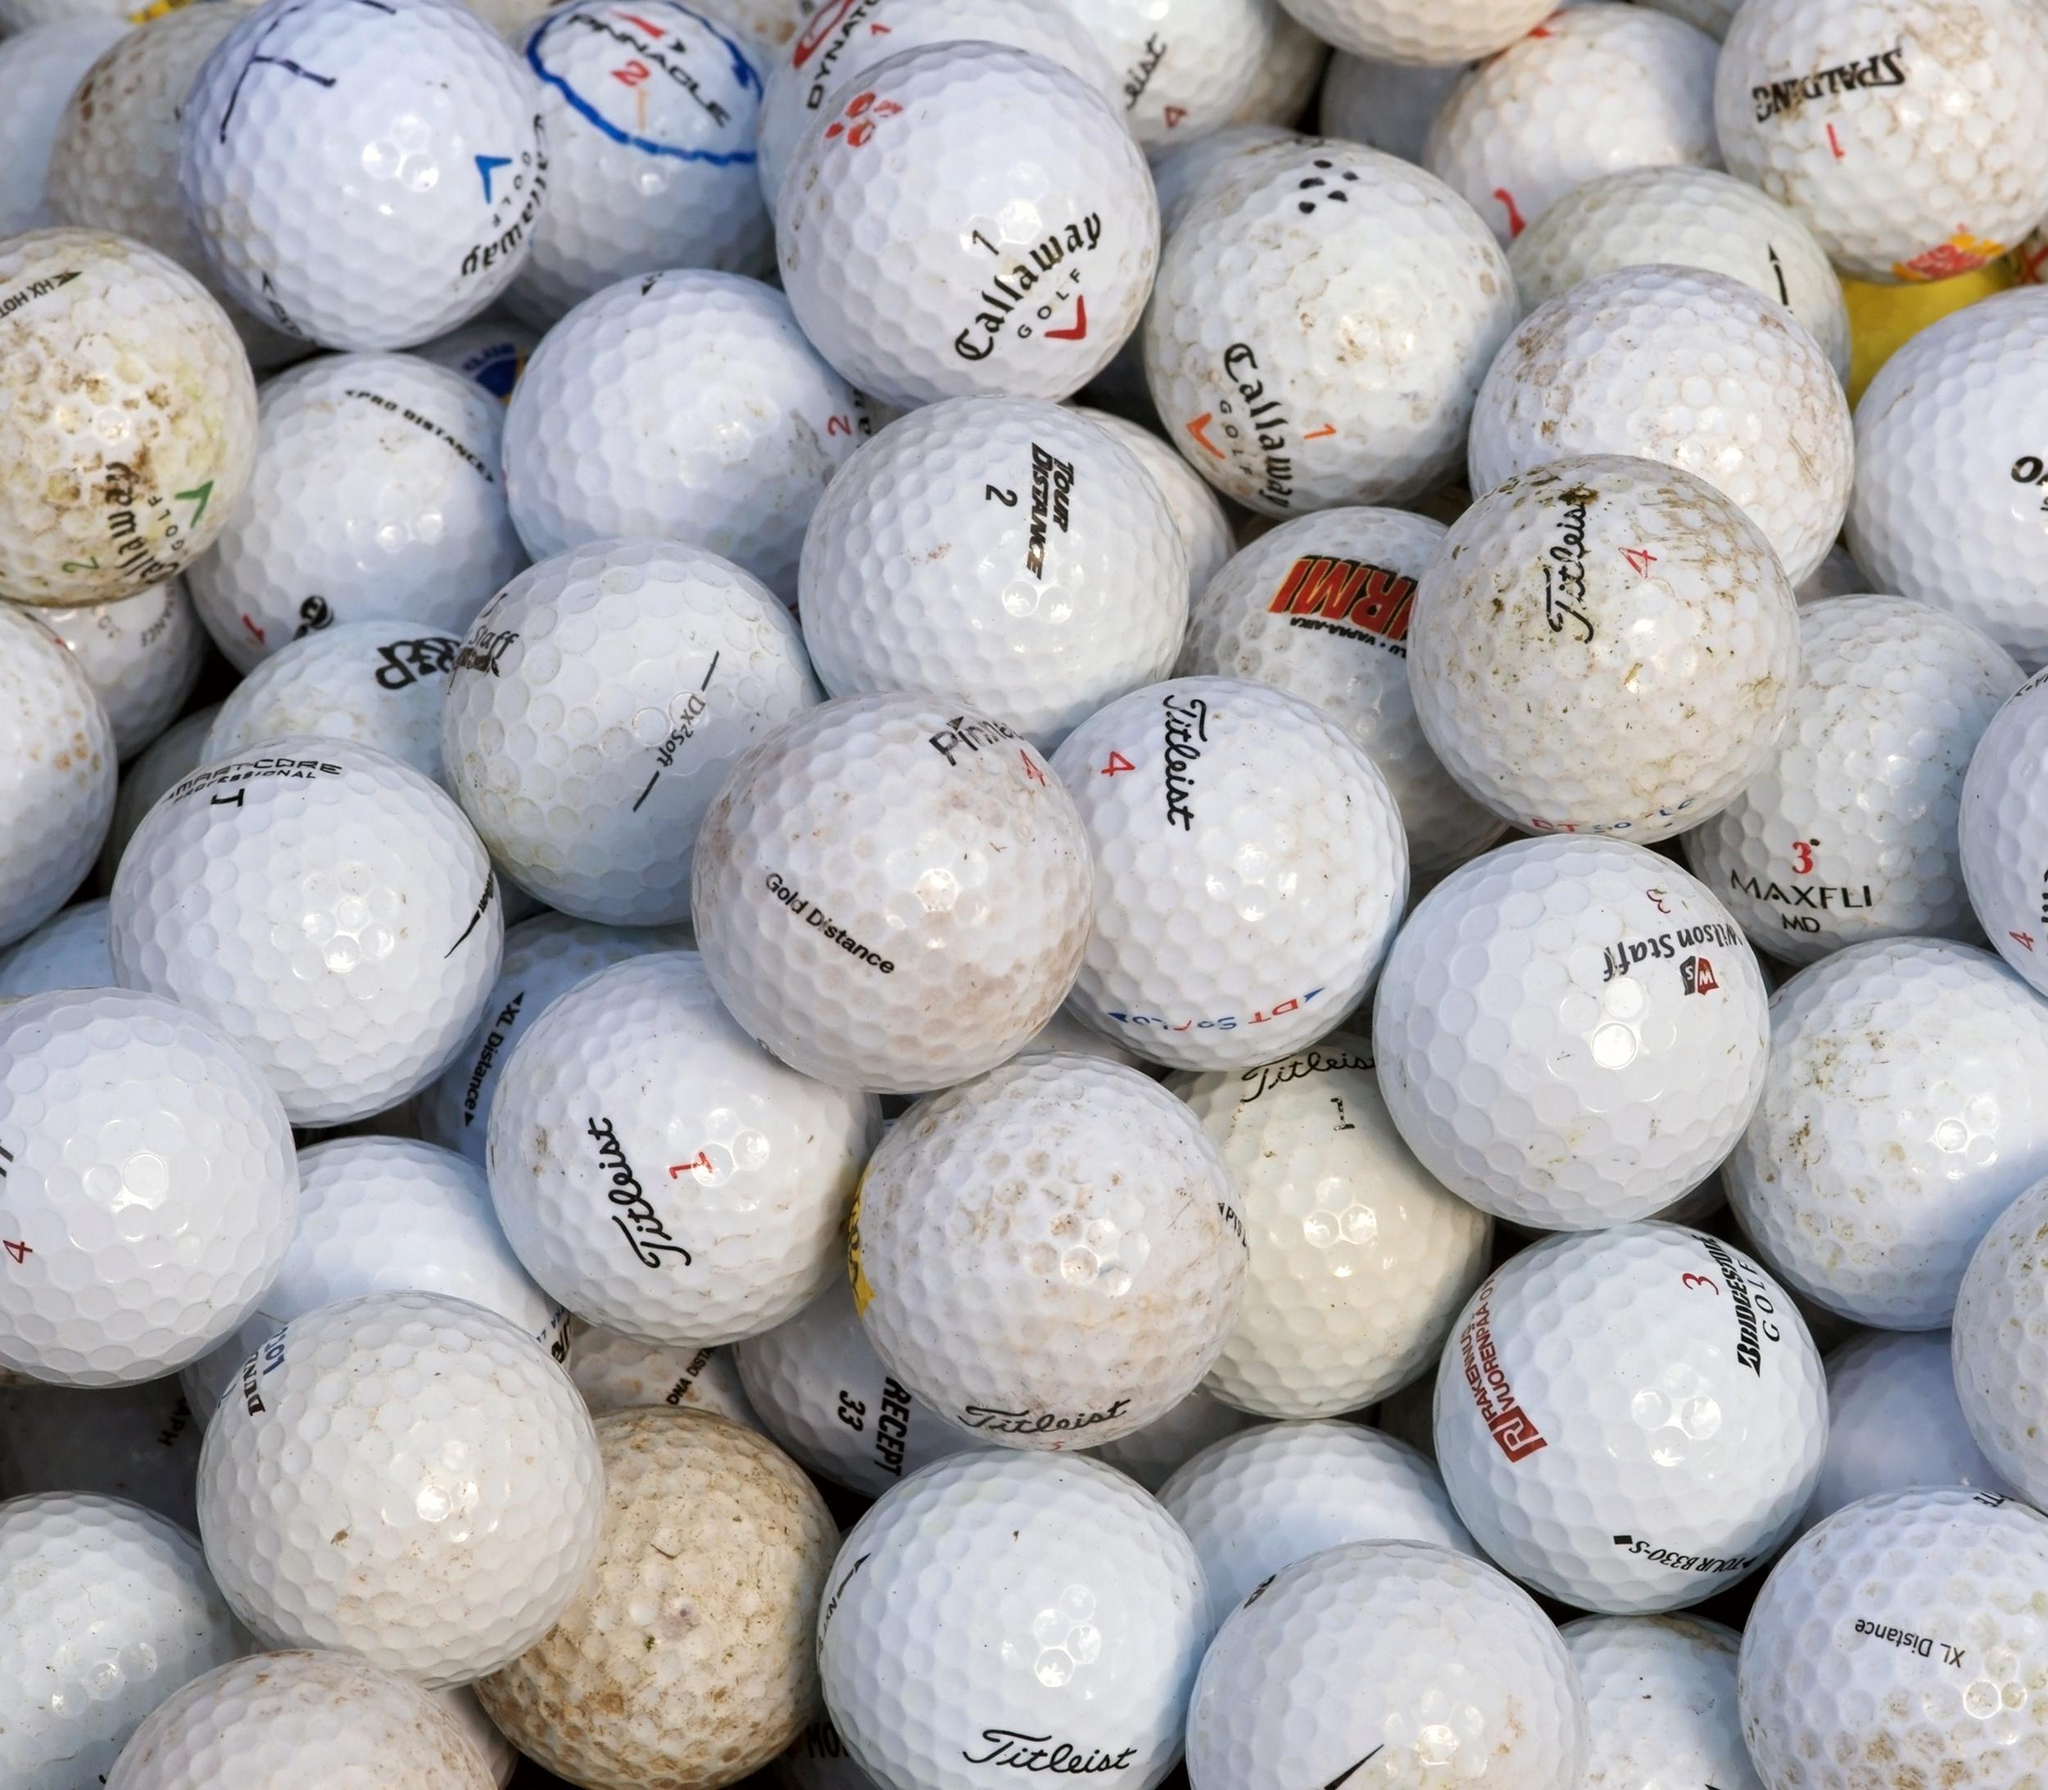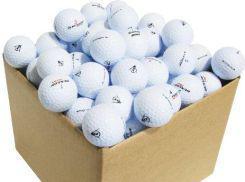The first image is the image on the left, the second image is the image on the right. Examine the images to the left and right. Is the description "One of the images contains nothing but golf balls, the other shows a brown that contains them." accurate? Answer yes or no. Yes. The first image is the image on the left, the second image is the image on the right. Assess this claim about the two images: "In at least in image there are at least thirty dirty and muddy golf balls.". Correct or not? Answer yes or no. Yes. 